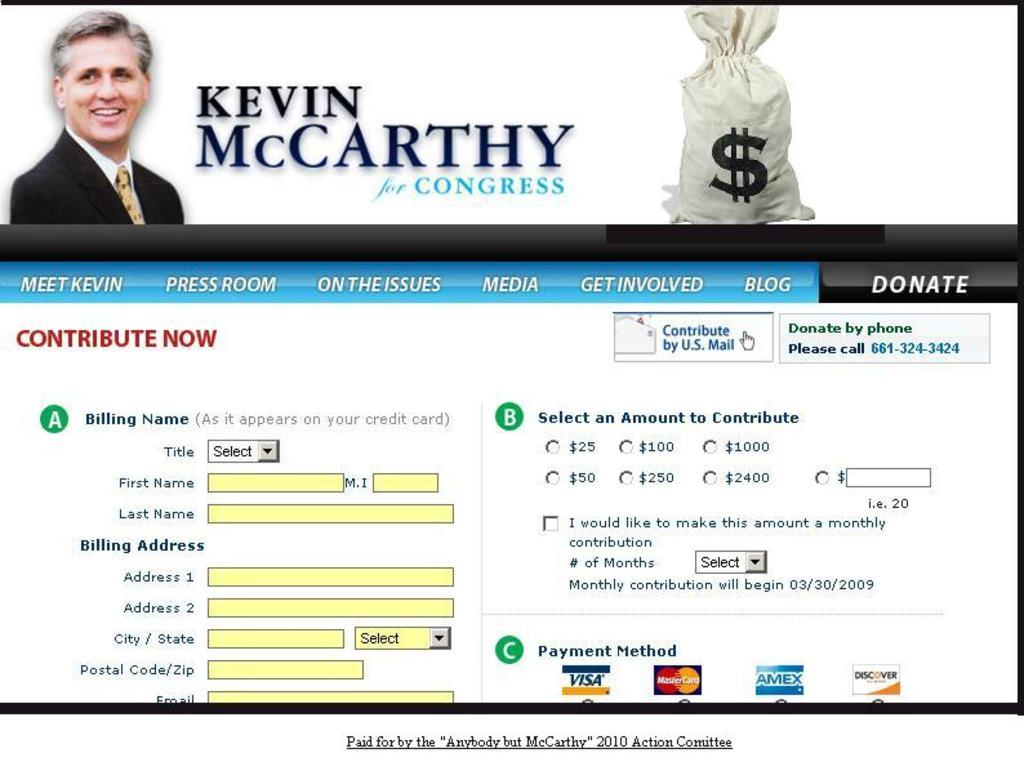What is the main object in the image? There is a display screen in the image. What can be seen on the display screen? There is text and pictures on the display screen. What type of cheese is being used in the battle depicted on the display screen? There is no battle or cheese present in the image; it only features a display screen with text and pictures. 